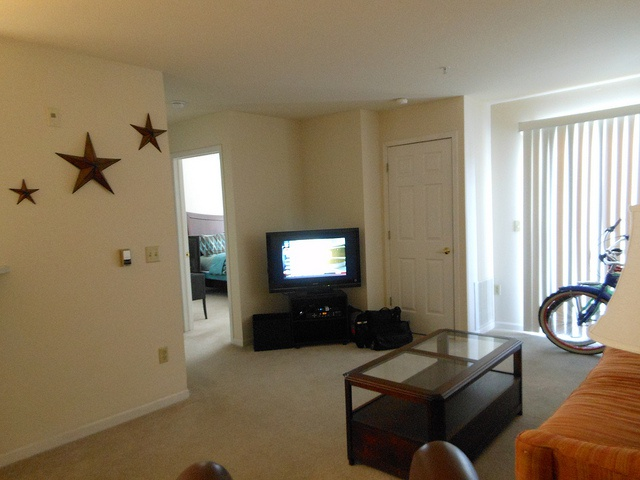Describe the objects in this image and their specific colors. I can see couch in tan, brown, maroon, and gray tones, tv in tan, black, white, navy, and blue tones, bicycle in tan, white, gray, darkgray, and black tones, bed in tan, darkgray, teal, and gray tones, and handbag in tan, black, and gray tones in this image. 